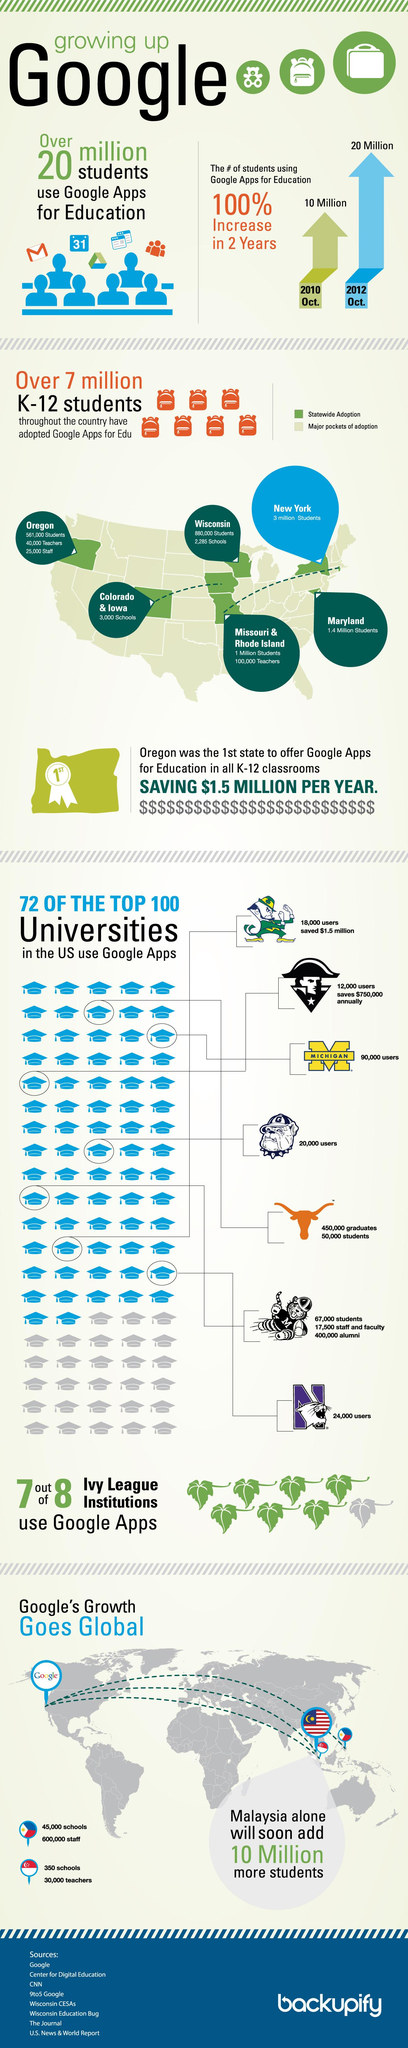Mention a couple of crucial points in this snapshot. Out of the 8 Ivy League institutions, only 1 did not use Google Apps. New York has the highest number of students adopting Google Apps statewide. During the period of 2010-2012, there has been a significant increase in the number of students using Google Apps for Education, with an estimated 10 million students utilizing these tools. The number of sources listed is 8. Seven states have adopted Google Apps for Education Statewide. 